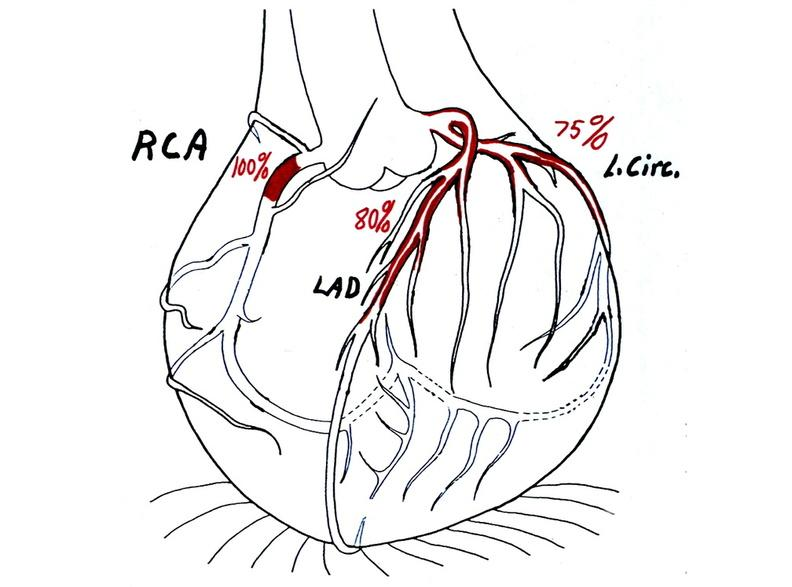s cardiovascular present?
Answer the question using a single word or phrase. Yes 